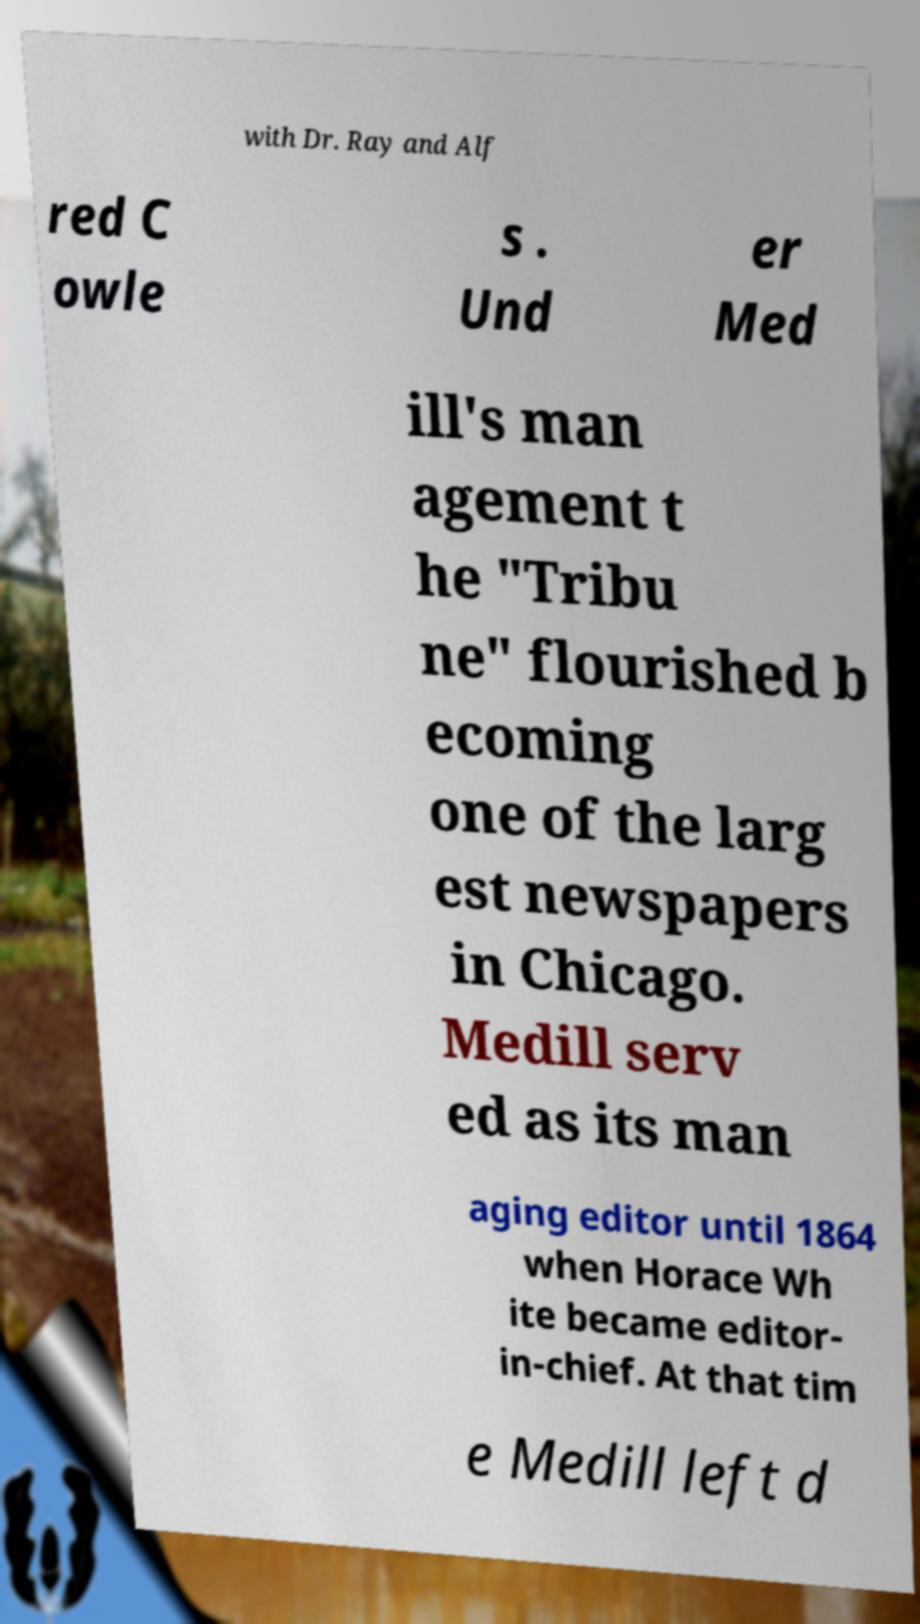I need the written content from this picture converted into text. Can you do that? with Dr. Ray and Alf red C owle s . Und er Med ill's man agement t he "Tribu ne" flourished b ecoming one of the larg est newspapers in Chicago. Medill serv ed as its man aging editor until 1864 when Horace Wh ite became editor- in-chief. At that tim e Medill left d 